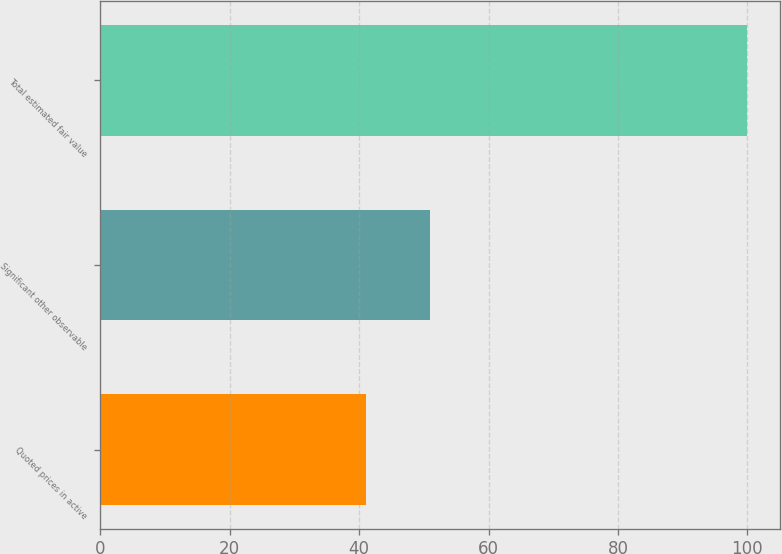Convert chart to OTSL. <chart><loc_0><loc_0><loc_500><loc_500><bar_chart><fcel>Quoted prices in active<fcel>Significant other observable<fcel>Total estimated fair value<nl><fcel>41<fcel>51<fcel>100<nl></chart> 